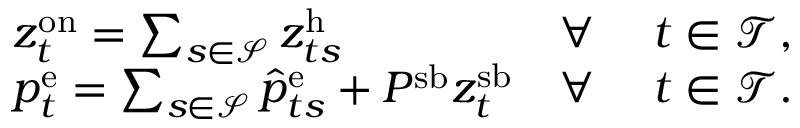Convert formula to latex. <formula><loc_0><loc_0><loc_500><loc_500>\begin{array} { r l r l } & { z _ { t } ^ { o n } = \sum _ { s \in \mathcal { S } } z _ { t s } ^ { h } } & { \forall } & { t \in \mathcal { T } , } \\ & { p _ { t } ^ { e } = \sum _ { s \in \mathcal { S } } \hat { p } _ { t s } ^ { e } + P ^ { s b } z _ { t } ^ { s b } } & { \forall } & { t \in \mathcal { T } . } \end{array}</formula> 